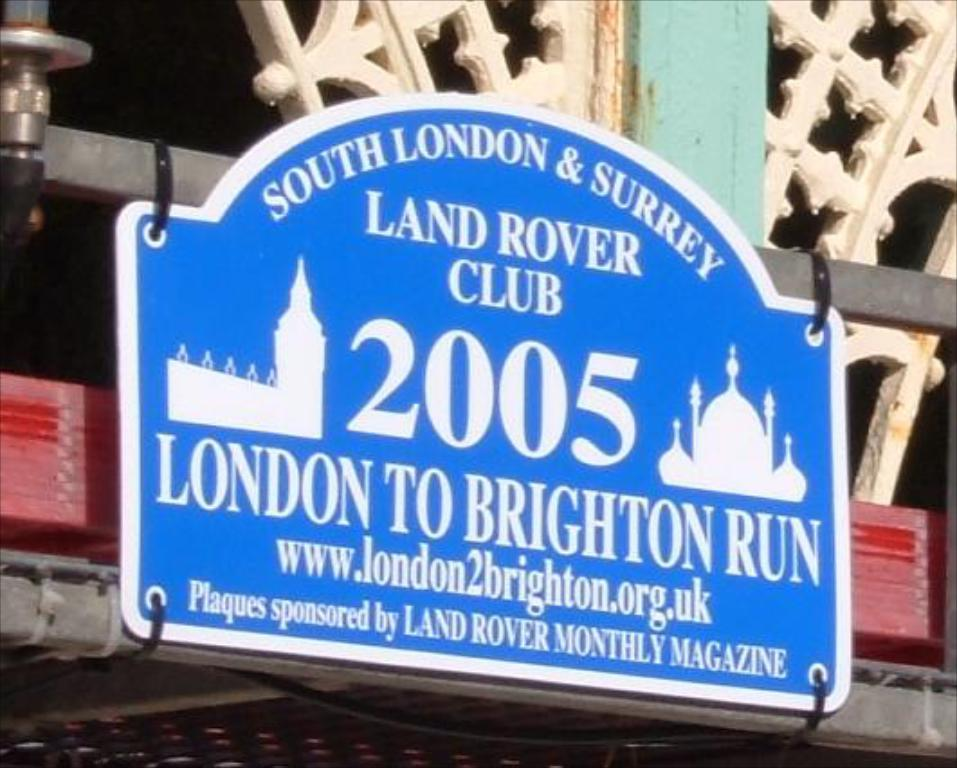<image>
Provide a brief description of the given image. A blue plaque sponsored by Land Rover Monthly Magazine is tied to metal rods. 